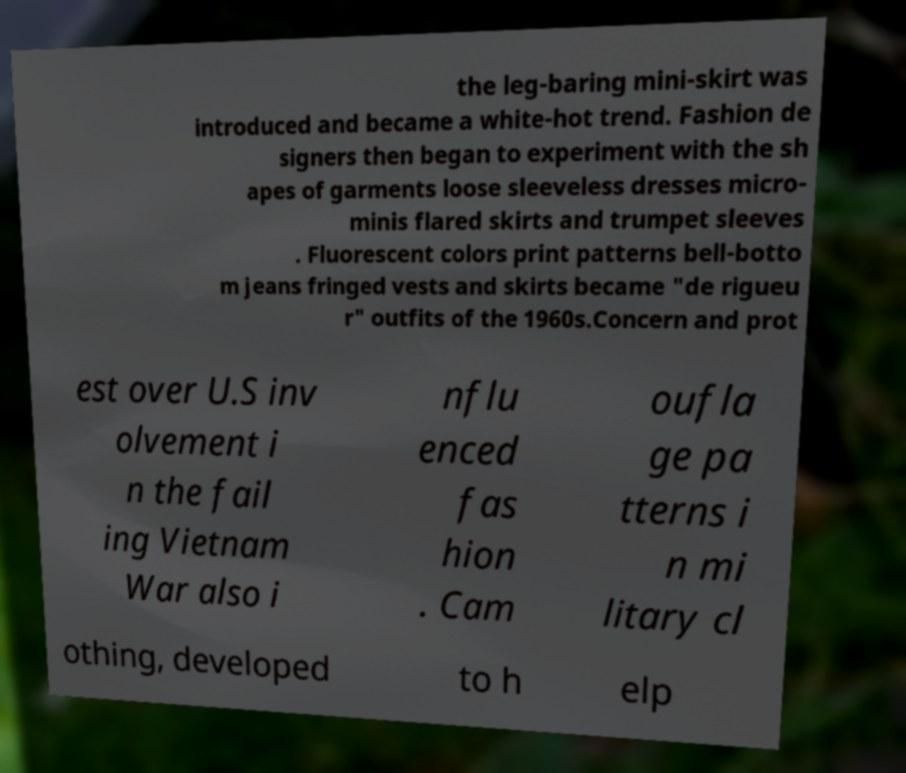Could you extract and type out the text from this image? the leg-baring mini-skirt was introduced and became a white-hot trend. Fashion de signers then began to experiment with the sh apes of garments loose sleeveless dresses micro- minis flared skirts and trumpet sleeves . Fluorescent colors print patterns bell-botto m jeans fringed vests and skirts became "de rigueu r" outfits of the 1960s.Concern and prot est over U.S inv olvement i n the fail ing Vietnam War also i nflu enced fas hion . Cam oufla ge pa tterns i n mi litary cl othing, developed to h elp 